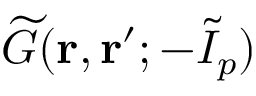Convert formula to latex. <formula><loc_0><loc_0><loc_500><loc_500>\widetilde { G } ( r , r ^ { \prime } ; { - } \widetilde { I } _ { p } )</formula> 